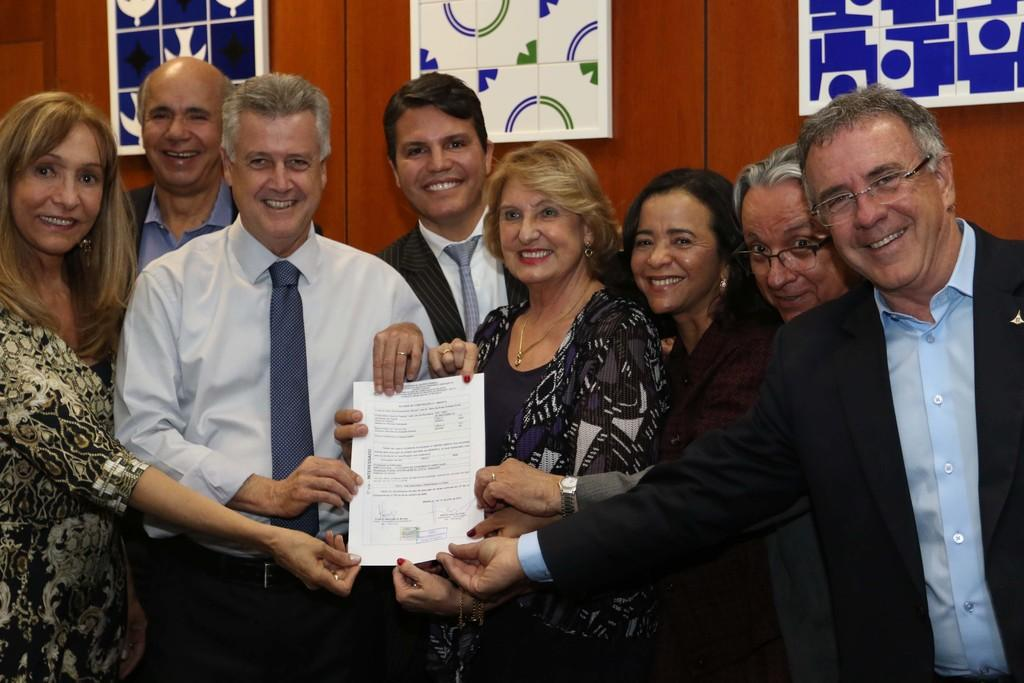What are the people in the image doing? The people in the image are standing and smiling. What are the people holding in the image? The people are holding a paper in the image. What can be seen in the background of the image? There is a wall in the background of the image. What is on the wall in the image? There are frames on the wall in the image. Can you tell me how many volcanoes are visible in the image? There are no volcanoes visible in the image; it features people standing and smiling while holding a paper. What type of scissors are being used by the people in the image? There are no scissors present in the image; the people are holding a paper. 